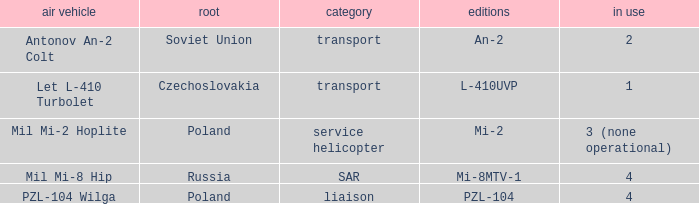Tell me the aircraft for pzl-104 PZL-104 Wilga. 